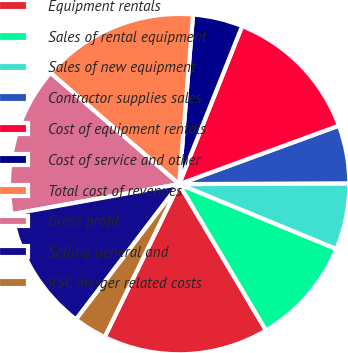Convert chart to OTSL. <chart><loc_0><loc_0><loc_500><loc_500><pie_chart><fcel>Equipment rentals<fcel>Sales of rental equipment<fcel>Sales of new equipment<fcel>Contractor supplies sales<fcel>Cost of equipment rentals<fcel>Cost of service and other<fcel>Total cost of revenues<fcel>Gross profit<fcel>Selling general and<fcel>RSC merger related costs<nl><fcel>15.74%<fcel>10.24%<fcel>6.3%<fcel>5.51%<fcel>13.38%<fcel>4.73%<fcel>14.96%<fcel>14.17%<fcel>11.81%<fcel>3.15%<nl></chart> 